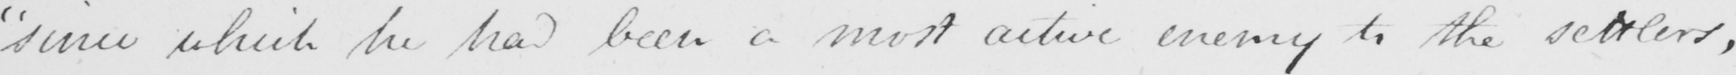Please transcribe the handwritten text in this image. " since which he had been a most active enemy to the settlers , 